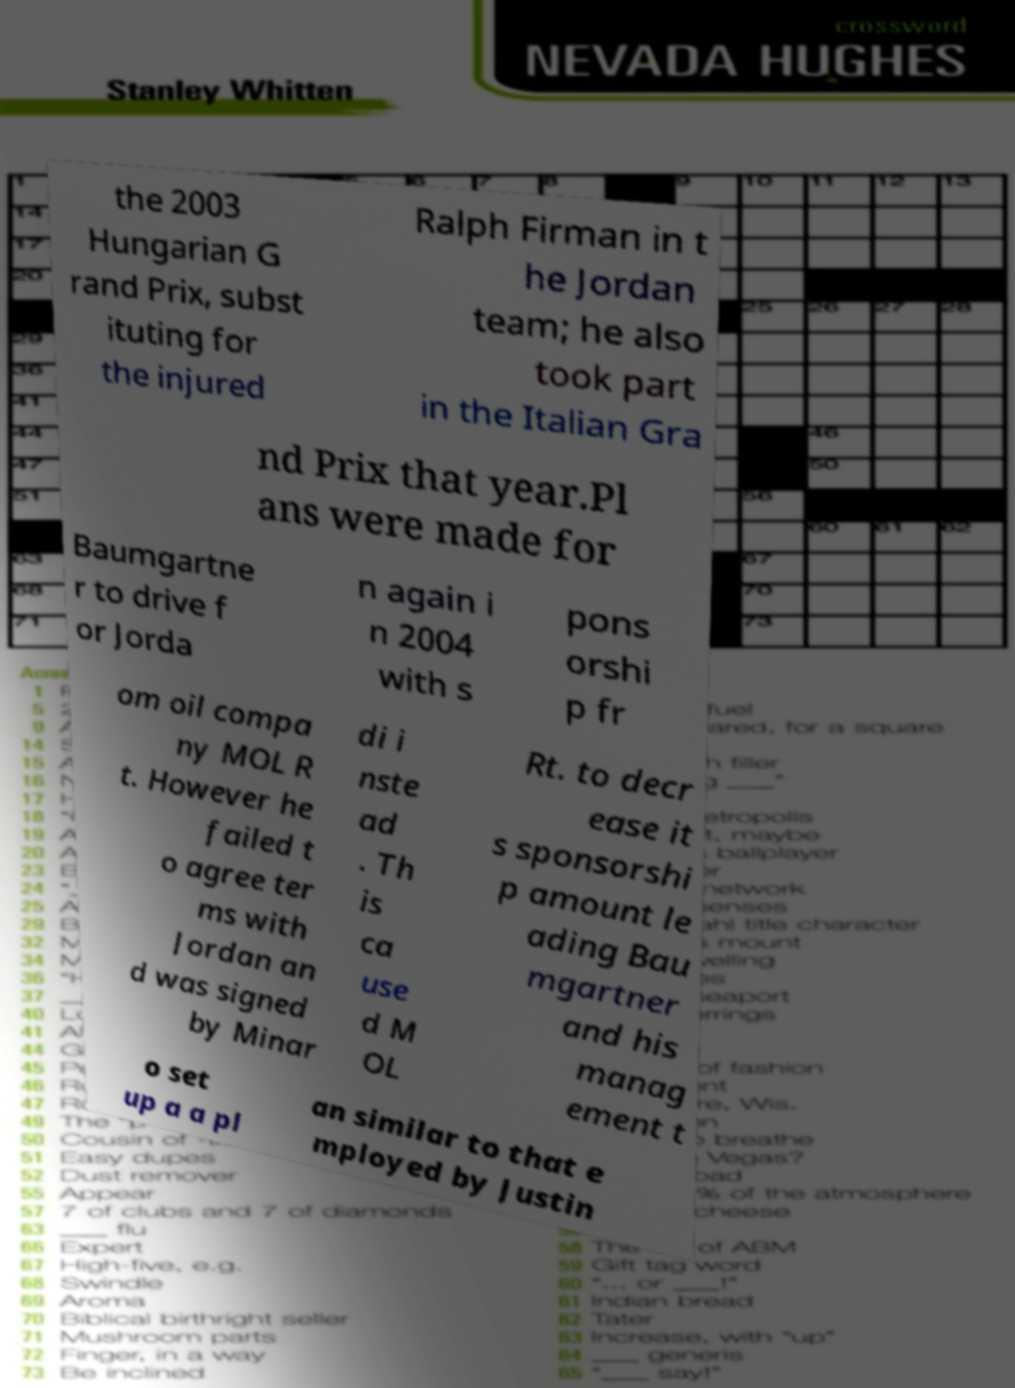Please identify and transcribe the text found in this image. the 2003 Hungarian G rand Prix, subst ituting for the injured Ralph Firman in t he Jordan team; he also took part in the Italian Gra nd Prix that year.Pl ans were made for Baumgartne r to drive f or Jorda n again i n 2004 with s pons orshi p fr om oil compa ny MOL R t. However he failed t o agree ter ms with Jordan an d was signed by Minar di i nste ad . Th is ca use d M OL Rt. to decr ease it s sponsorshi p amount le ading Bau mgartner and his manag ement t o set up a a pl an similar to that e mployed by Justin 